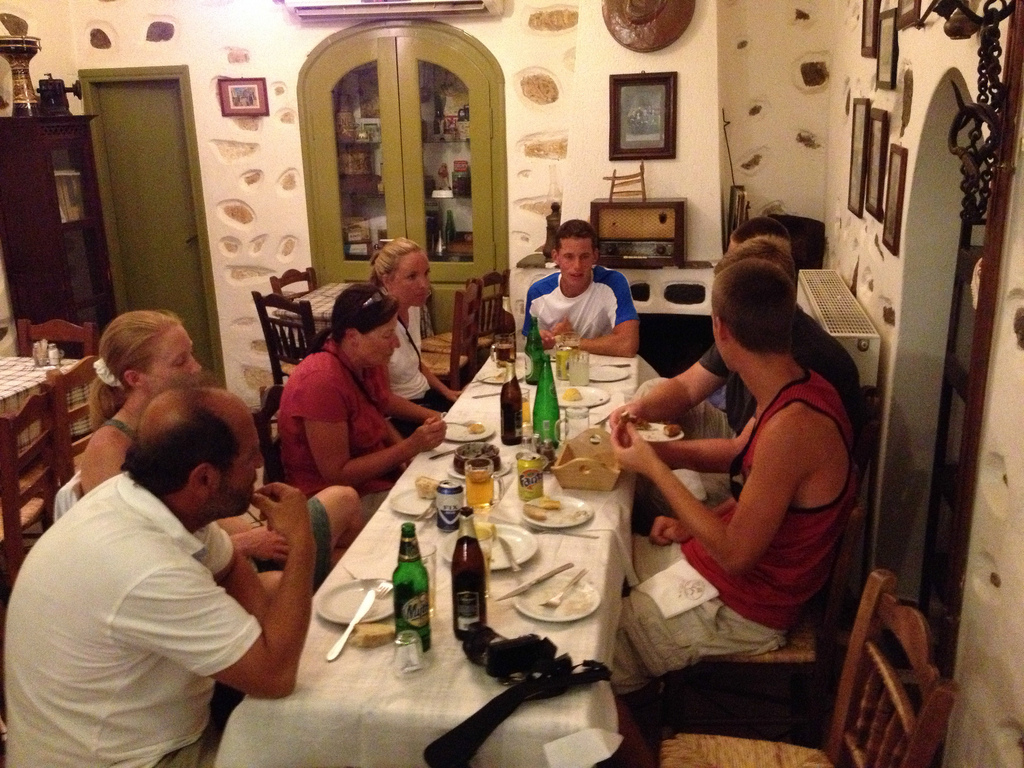Can you describe what the people at the table seem to be doing? The individuals around the table appear to be deeply engaged in their mealtime conversation, with varying expressions of interest and enjoyment. Plates of food, bottles, and glasses indicate they are in the middle of dinner. 